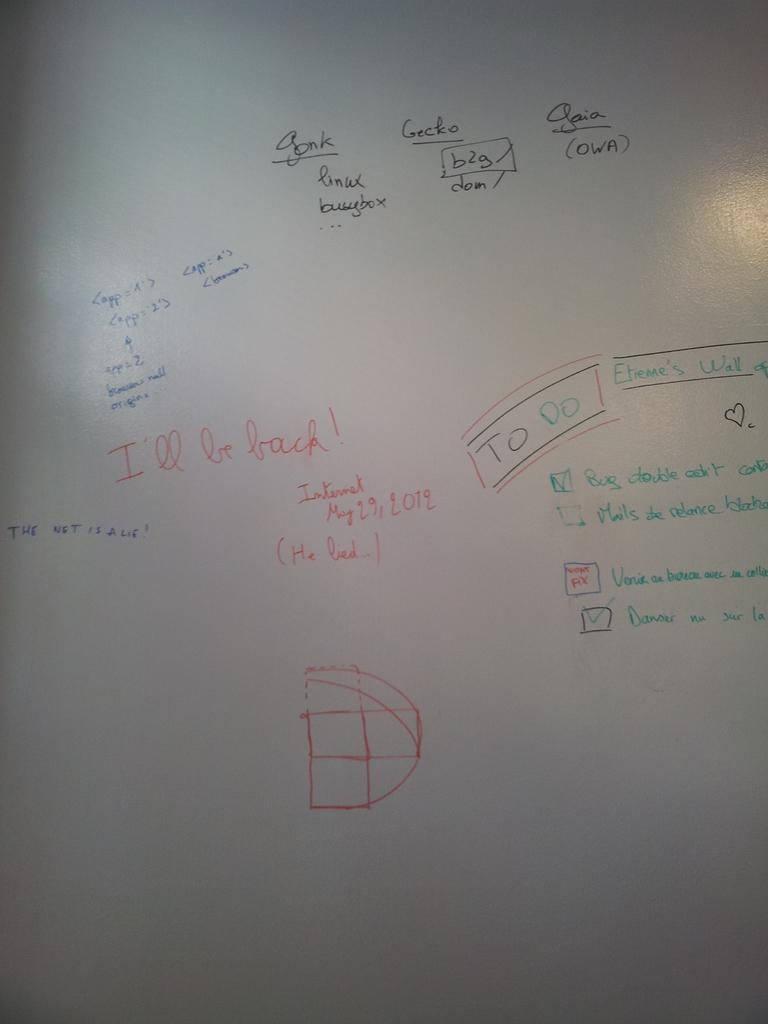<image>
Give a short and clear explanation of the subsequent image. scrawls in different colour pen on a white background, one of which reads 'I'll be back' 